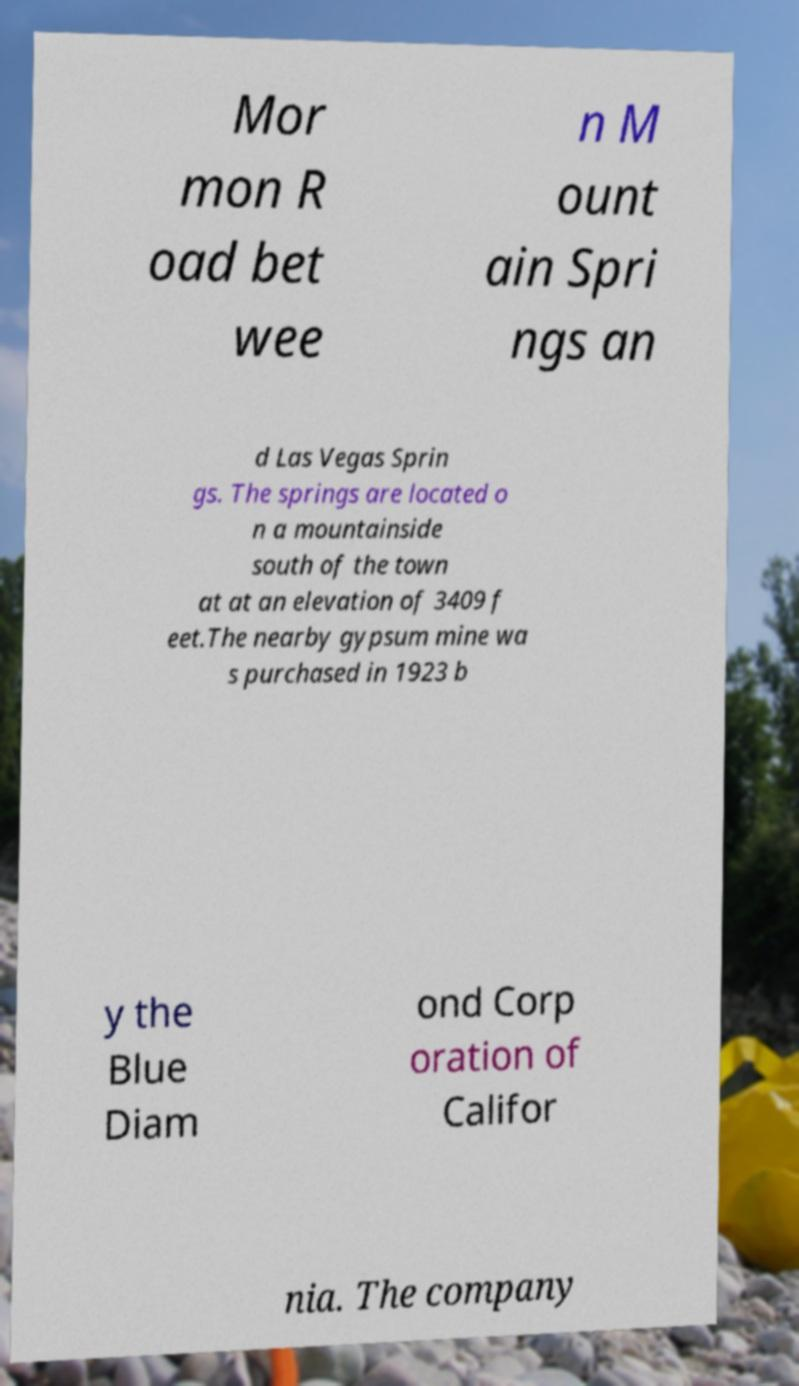Please identify and transcribe the text found in this image. Mor mon R oad bet wee n M ount ain Spri ngs an d Las Vegas Sprin gs. The springs are located o n a mountainside south of the town at at an elevation of 3409 f eet.The nearby gypsum mine wa s purchased in 1923 b y the Blue Diam ond Corp oration of Califor nia. The company 